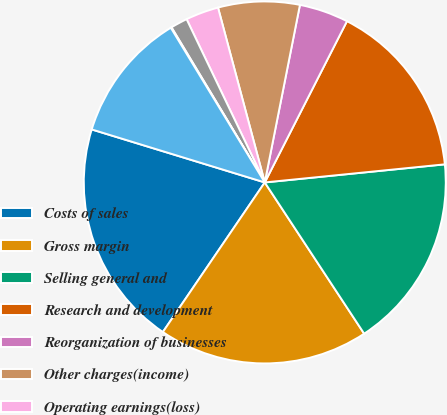Convert chart to OTSL. <chart><loc_0><loc_0><loc_500><loc_500><pie_chart><fcel>Costs of sales<fcel>Gross margin<fcel>Selling general and<fcel>Research and development<fcel>Reorganization of businesses<fcel>Other charges(income)<fcel>Operating earnings(loss)<fcel>Interest expense net<fcel>Gains on sales of investments<fcel>Other<nl><fcel>20.21%<fcel>18.77%<fcel>17.34%<fcel>15.9%<fcel>4.39%<fcel>7.27%<fcel>2.95%<fcel>1.51%<fcel>0.07%<fcel>11.58%<nl></chart> 